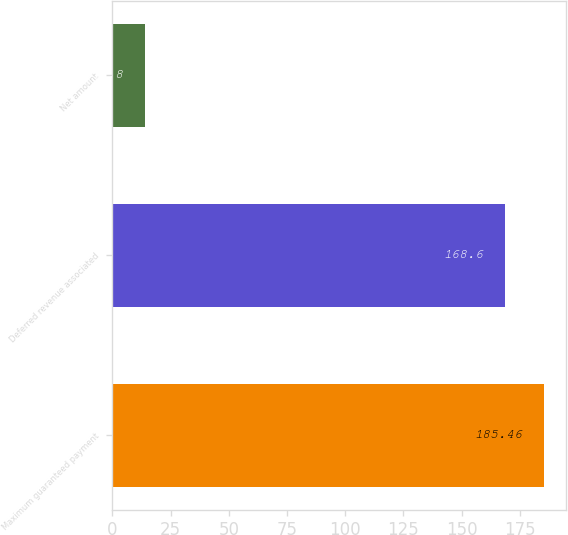Convert chart to OTSL. <chart><loc_0><loc_0><loc_500><loc_500><bar_chart><fcel>Maximum guaranteed payment<fcel>Deferred revenue associated<fcel>Net amount<nl><fcel>185.46<fcel>168.6<fcel>13.8<nl></chart> 